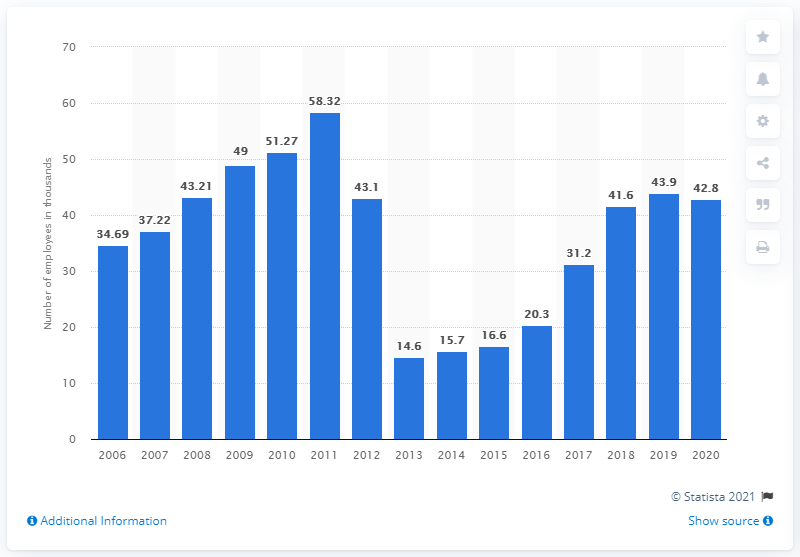Give some essential details in this illustration. In 2020, Vivendi had a total of 42.8 employees. 